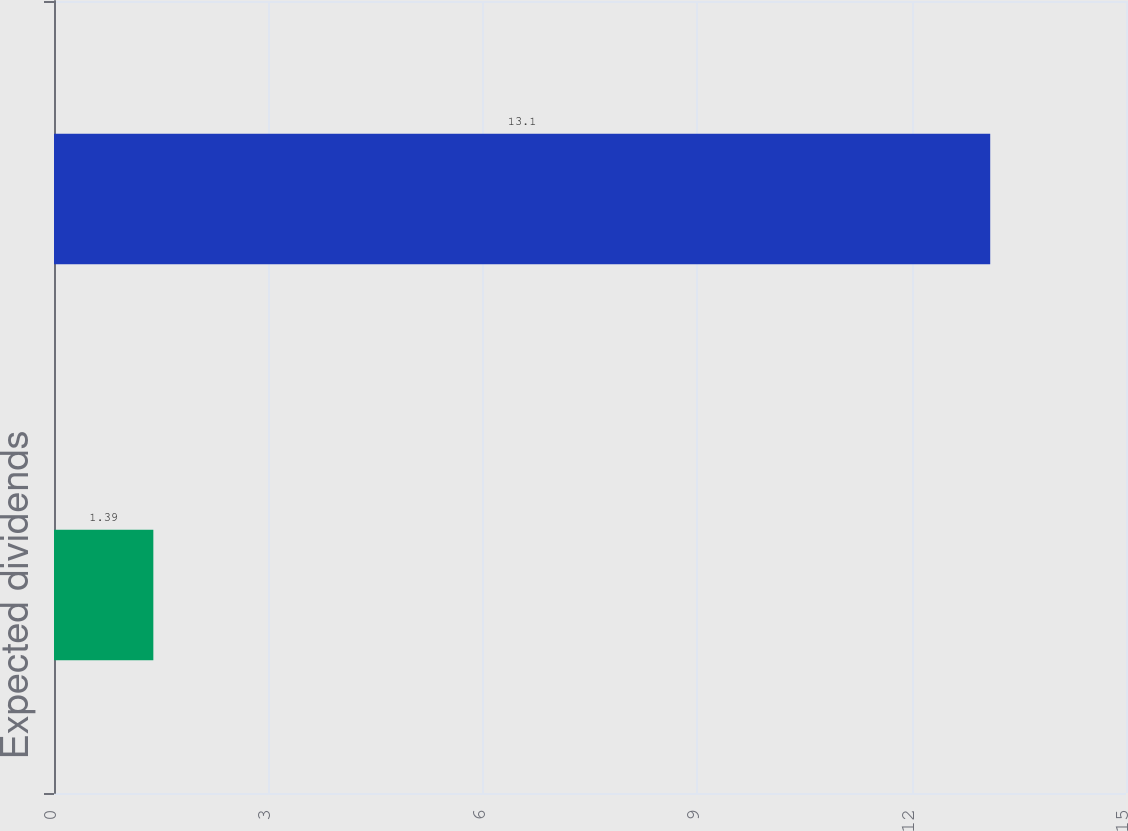Convert chart to OTSL. <chart><loc_0><loc_0><loc_500><loc_500><bar_chart><fcel>Expected dividends<fcel>Expected forfeitures<nl><fcel>1.39<fcel>13.1<nl></chart> 